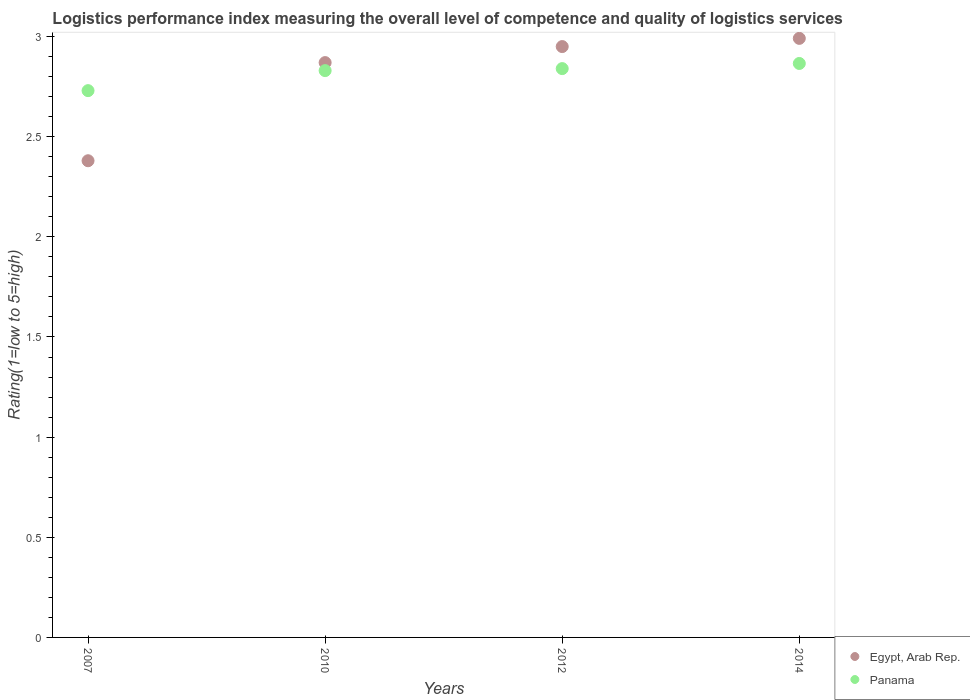How many different coloured dotlines are there?
Offer a very short reply. 2. What is the Logistic performance index in Egypt, Arab Rep. in 2007?
Ensure brevity in your answer.  2.38. Across all years, what is the maximum Logistic performance index in Egypt, Arab Rep.?
Offer a very short reply. 2.99. Across all years, what is the minimum Logistic performance index in Egypt, Arab Rep.?
Offer a terse response. 2.38. What is the total Logistic performance index in Panama in the graph?
Keep it short and to the point. 11.27. What is the difference between the Logistic performance index in Panama in 2007 and that in 2010?
Give a very brief answer. -0.1. What is the difference between the Logistic performance index in Egypt, Arab Rep. in 2010 and the Logistic performance index in Panama in 2012?
Offer a terse response. 0.03. What is the average Logistic performance index in Egypt, Arab Rep. per year?
Offer a terse response. 2.8. In the year 2007, what is the difference between the Logistic performance index in Panama and Logistic performance index in Egypt, Arab Rep.?
Ensure brevity in your answer.  0.35. What is the ratio of the Logistic performance index in Panama in 2010 to that in 2014?
Give a very brief answer. 0.99. What is the difference between the highest and the second highest Logistic performance index in Egypt, Arab Rep.?
Ensure brevity in your answer.  0.04. What is the difference between the highest and the lowest Logistic performance index in Egypt, Arab Rep.?
Ensure brevity in your answer.  0.61. In how many years, is the Logistic performance index in Egypt, Arab Rep. greater than the average Logistic performance index in Egypt, Arab Rep. taken over all years?
Your answer should be very brief. 3. Is the Logistic performance index in Egypt, Arab Rep. strictly greater than the Logistic performance index in Panama over the years?
Your response must be concise. No. How many dotlines are there?
Keep it short and to the point. 2. What is the difference between two consecutive major ticks on the Y-axis?
Make the answer very short. 0.5. Are the values on the major ticks of Y-axis written in scientific E-notation?
Offer a very short reply. No. Does the graph contain any zero values?
Provide a short and direct response. No. Does the graph contain grids?
Make the answer very short. No. Where does the legend appear in the graph?
Offer a terse response. Bottom right. What is the title of the graph?
Offer a very short reply. Logistics performance index measuring the overall level of competence and quality of logistics services. What is the label or title of the X-axis?
Your response must be concise. Years. What is the label or title of the Y-axis?
Make the answer very short. Rating(1=low to 5=high). What is the Rating(1=low to 5=high) in Egypt, Arab Rep. in 2007?
Make the answer very short. 2.38. What is the Rating(1=low to 5=high) of Panama in 2007?
Make the answer very short. 2.73. What is the Rating(1=low to 5=high) of Egypt, Arab Rep. in 2010?
Your answer should be compact. 2.87. What is the Rating(1=low to 5=high) in Panama in 2010?
Provide a succinct answer. 2.83. What is the Rating(1=low to 5=high) of Egypt, Arab Rep. in 2012?
Make the answer very short. 2.95. What is the Rating(1=low to 5=high) of Panama in 2012?
Offer a very short reply. 2.84. What is the Rating(1=low to 5=high) in Egypt, Arab Rep. in 2014?
Your response must be concise. 2.99. What is the Rating(1=low to 5=high) in Panama in 2014?
Your answer should be compact. 2.87. Across all years, what is the maximum Rating(1=low to 5=high) of Egypt, Arab Rep.?
Your answer should be compact. 2.99. Across all years, what is the maximum Rating(1=low to 5=high) in Panama?
Keep it short and to the point. 2.87. Across all years, what is the minimum Rating(1=low to 5=high) of Egypt, Arab Rep.?
Make the answer very short. 2.38. Across all years, what is the minimum Rating(1=low to 5=high) in Panama?
Offer a very short reply. 2.73. What is the total Rating(1=low to 5=high) of Egypt, Arab Rep. in the graph?
Your answer should be compact. 11.19. What is the total Rating(1=low to 5=high) of Panama in the graph?
Provide a short and direct response. 11.27. What is the difference between the Rating(1=low to 5=high) of Egypt, Arab Rep. in 2007 and that in 2010?
Provide a short and direct response. -0.49. What is the difference between the Rating(1=low to 5=high) in Panama in 2007 and that in 2010?
Give a very brief answer. -0.1. What is the difference between the Rating(1=low to 5=high) of Egypt, Arab Rep. in 2007 and that in 2012?
Keep it short and to the point. -0.57. What is the difference between the Rating(1=low to 5=high) in Panama in 2007 and that in 2012?
Ensure brevity in your answer.  -0.11. What is the difference between the Rating(1=low to 5=high) of Egypt, Arab Rep. in 2007 and that in 2014?
Offer a very short reply. -0.61. What is the difference between the Rating(1=low to 5=high) of Panama in 2007 and that in 2014?
Give a very brief answer. -0.14. What is the difference between the Rating(1=low to 5=high) of Egypt, Arab Rep. in 2010 and that in 2012?
Your answer should be compact. -0.08. What is the difference between the Rating(1=low to 5=high) of Panama in 2010 and that in 2012?
Provide a succinct answer. -0.01. What is the difference between the Rating(1=low to 5=high) of Egypt, Arab Rep. in 2010 and that in 2014?
Your answer should be very brief. -0.12. What is the difference between the Rating(1=low to 5=high) in Panama in 2010 and that in 2014?
Provide a short and direct response. -0.04. What is the difference between the Rating(1=low to 5=high) in Egypt, Arab Rep. in 2012 and that in 2014?
Keep it short and to the point. -0.04. What is the difference between the Rating(1=low to 5=high) in Panama in 2012 and that in 2014?
Provide a succinct answer. -0.03. What is the difference between the Rating(1=low to 5=high) in Egypt, Arab Rep. in 2007 and the Rating(1=low to 5=high) in Panama in 2010?
Your answer should be compact. -0.45. What is the difference between the Rating(1=low to 5=high) of Egypt, Arab Rep. in 2007 and the Rating(1=low to 5=high) of Panama in 2012?
Your answer should be very brief. -0.46. What is the difference between the Rating(1=low to 5=high) of Egypt, Arab Rep. in 2007 and the Rating(1=low to 5=high) of Panama in 2014?
Your answer should be compact. -0.49. What is the difference between the Rating(1=low to 5=high) of Egypt, Arab Rep. in 2010 and the Rating(1=low to 5=high) of Panama in 2012?
Your response must be concise. 0.03. What is the difference between the Rating(1=low to 5=high) in Egypt, Arab Rep. in 2010 and the Rating(1=low to 5=high) in Panama in 2014?
Your answer should be very brief. 0. What is the difference between the Rating(1=low to 5=high) of Egypt, Arab Rep. in 2012 and the Rating(1=low to 5=high) of Panama in 2014?
Your response must be concise. 0.08. What is the average Rating(1=low to 5=high) of Egypt, Arab Rep. per year?
Keep it short and to the point. 2.8. What is the average Rating(1=low to 5=high) in Panama per year?
Your answer should be very brief. 2.82. In the year 2007, what is the difference between the Rating(1=low to 5=high) in Egypt, Arab Rep. and Rating(1=low to 5=high) in Panama?
Give a very brief answer. -0.35. In the year 2012, what is the difference between the Rating(1=low to 5=high) in Egypt, Arab Rep. and Rating(1=low to 5=high) in Panama?
Make the answer very short. 0.11. In the year 2014, what is the difference between the Rating(1=low to 5=high) of Egypt, Arab Rep. and Rating(1=low to 5=high) of Panama?
Offer a terse response. 0.13. What is the ratio of the Rating(1=low to 5=high) in Egypt, Arab Rep. in 2007 to that in 2010?
Keep it short and to the point. 0.83. What is the ratio of the Rating(1=low to 5=high) of Panama in 2007 to that in 2010?
Your answer should be very brief. 0.96. What is the ratio of the Rating(1=low to 5=high) in Egypt, Arab Rep. in 2007 to that in 2012?
Offer a terse response. 0.81. What is the ratio of the Rating(1=low to 5=high) of Panama in 2007 to that in 2012?
Your answer should be very brief. 0.96. What is the ratio of the Rating(1=low to 5=high) of Egypt, Arab Rep. in 2007 to that in 2014?
Your answer should be compact. 0.8. What is the ratio of the Rating(1=low to 5=high) in Panama in 2007 to that in 2014?
Your answer should be very brief. 0.95. What is the ratio of the Rating(1=low to 5=high) in Egypt, Arab Rep. in 2010 to that in 2012?
Your answer should be compact. 0.97. What is the ratio of the Rating(1=low to 5=high) of Egypt, Arab Rep. in 2010 to that in 2014?
Your response must be concise. 0.96. What is the ratio of the Rating(1=low to 5=high) in Panama in 2010 to that in 2014?
Give a very brief answer. 0.99. What is the ratio of the Rating(1=low to 5=high) of Egypt, Arab Rep. in 2012 to that in 2014?
Give a very brief answer. 0.99. What is the ratio of the Rating(1=low to 5=high) in Panama in 2012 to that in 2014?
Keep it short and to the point. 0.99. What is the difference between the highest and the second highest Rating(1=low to 5=high) of Egypt, Arab Rep.?
Provide a succinct answer. 0.04. What is the difference between the highest and the second highest Rating(1=low to 5=high) in Panama?
Provide a short and direct response. 0.03. What is the difference between the highest and the lowest Rating(1=low to 5=high) in Egypt, Arab Rep.?
Offer a terse response. 0.61. What is the difference between the highest and the lowest Rating(1=low to 5=high) in Panama?
Offer a terse response. 0.14. 